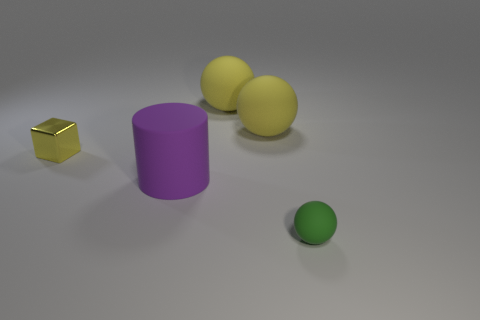What material is the yellow thing that is the same size as the green matte thing?
Your answer should be very brief. Metal. Are there any cylinders of the same size as the metallic object?
Your answer should be compact. No. There is a matte ball that is in front of the tiny block; what is its color?
Provide a short and direct response. Green. Are there any objects that are left of the sphere in front of the block?
Offer a very short reply. Yes. What number of other objects are there of the same color as the small rubber thing?
Offer a very short reply. 0. There is a matte sphere that is in front of the purple cylinder; is its size the same as the thing that is left of the big purple cylinder?
Your answer should be very brief. Yes. What size is the matte sphere in front of the small object that is behind the big matte cylinder?
Your answer should be very brief. Small. What material is the object that is both right of the big cylinder and in front of the metal block?
Your answer should be very brief. Rubber. The cylinder is what color?
Keep it short and to the point. Purple. Are there any other things that have the same material as the block?
Offer a very short reply. No. 